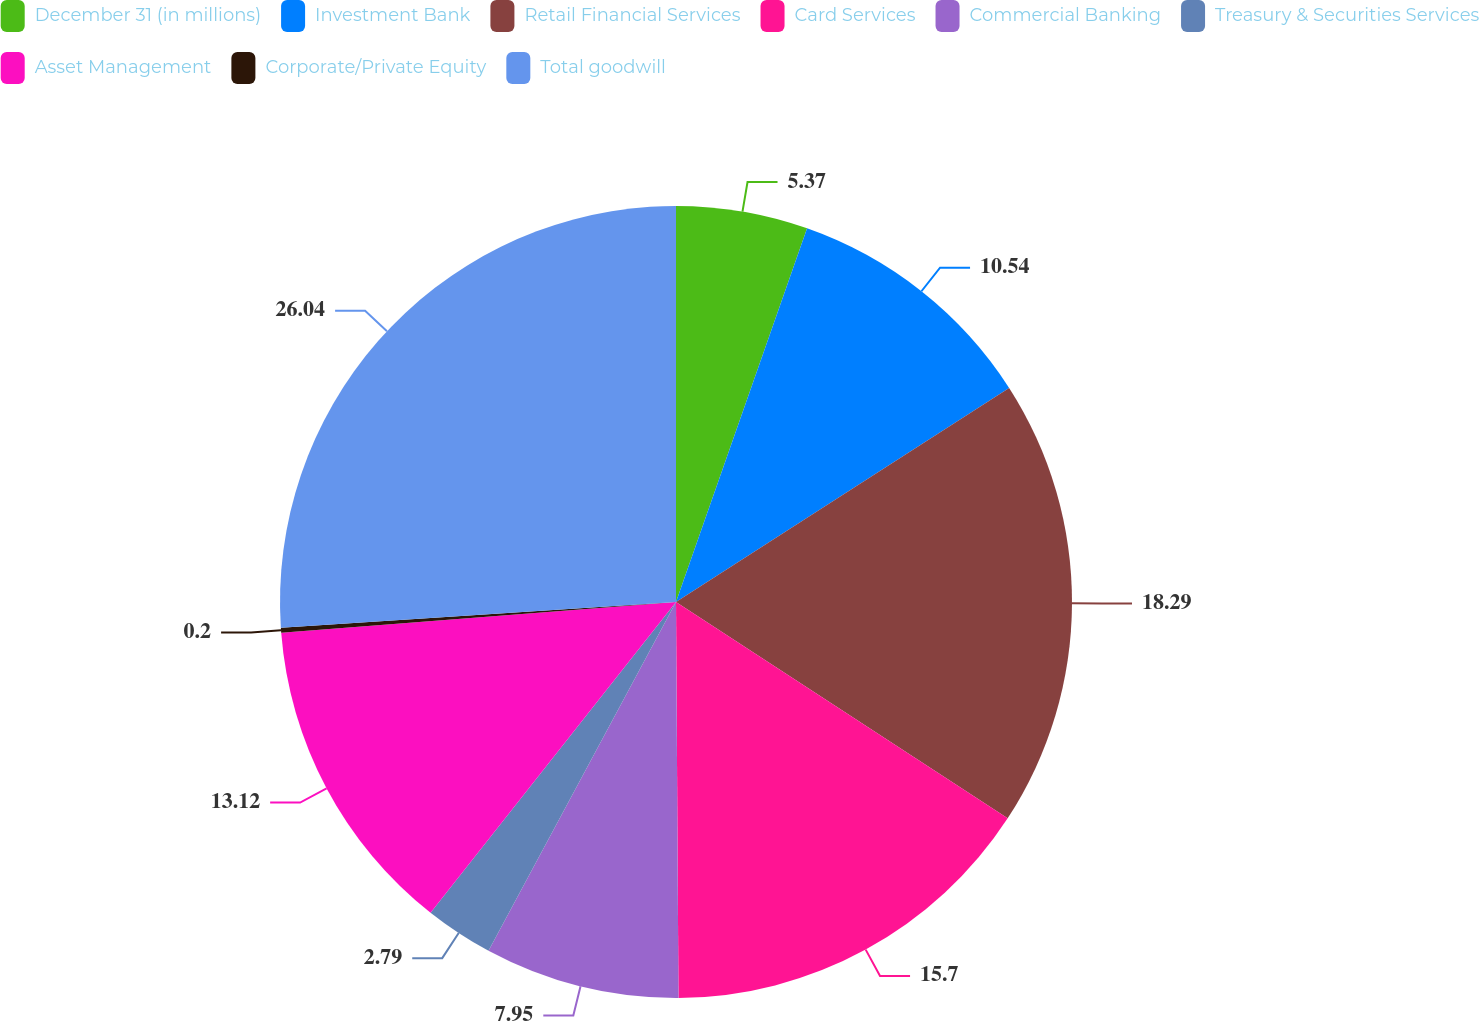Convert chart. <chart><loc_0><loc_0><loc_500><loc_500><pie_chart><fcel>December 31 (in millions)<fcel>Investment Bank<fcel>Retail Financial Services<fcel>Card Services<fcel>Commercial Banking<fcel>Treasury & Securities Services<fcel>Asset Management<fcel>Corporate/Private Equity<fcel>Total goodwill<nl><fcel>5.37%<fcel>10.54%<fcel>18.29%<fcel>15.7%<fcel>7.95%<fcel>2.79%<fcel>13.12%<fcel>0.2%<fcel>26.04%<nl></chart> 